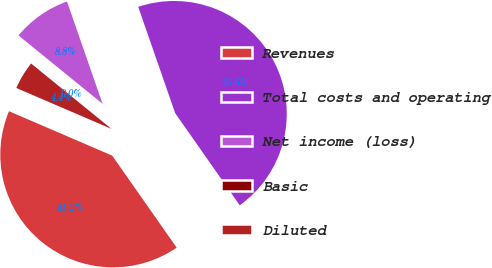Convert chart to OTSL. <chart><loc_0><loc_0><loc_500><loc_500><pie_chart><fcel>Revenues<fcel>Total costs and operating<fcel>Net income (loss)<fcel>Basic<fcel>Diluted<nl><fcel>41.19%<fcel>45.6%<fcel>8.81%<fcel>0.0%<fcel>4.4%<nl></chart> 